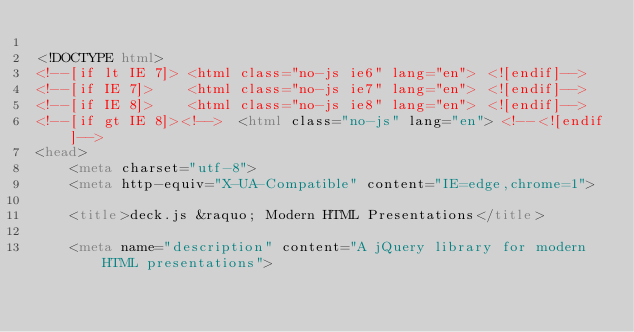Convert code to text. <code><loc_0><loc_0><loc_500><loc_500><_HTML_>
<!DOCTYPE html>
<!--[if lt IE 7]> <html class="no-js ie6" lang="en"> <![endif]-->
<!--[if IE 7]>    <html class="no-js ie7" lang="en"> <![endif]-->
<!--[if IE 8]>    <html class="no-js ie8" lang="en"> <![endif]-->
<!--[if gt IE 8]><!-->  <html class="no-js" lang="en"> <!--<![endif]-->
<head>
	<meta charset="utf-8">
	<meta http-equiv="X-UA-Compatible" content="IE=edge,chrome=1">
	
	<title>deck.js &raquo; Modern HTML Presentations</title>
	
	<meta name="description" content="A jQuery library for modern HTML presentations"></code> 